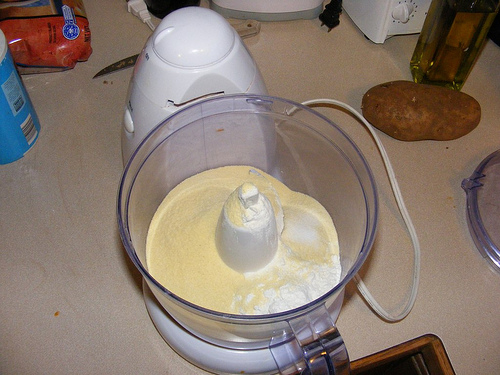<image>
Can you confirm if the flour is in the mixer? No. The flour is not contained within the mixer. These objects have a different spatial relationship. 